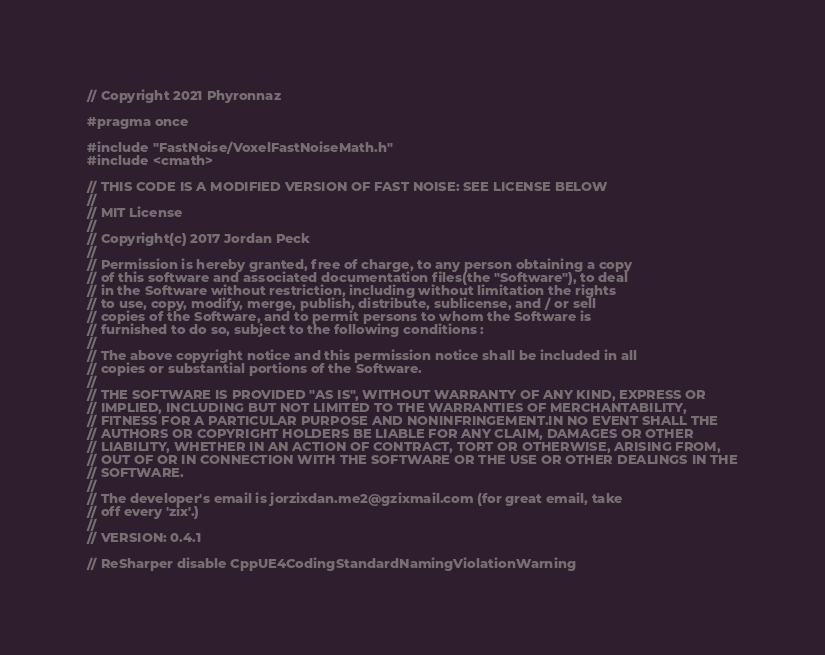Convert code to text. <code><loc_0><loc_0><loc_500><loc_500><_C++_>// Copyright 2021 Phyronnaz

#pragma once

#include "FastNoise/VoxelFastNoiseMath.h"
#include <cmath>

// THIS CODE IS A MODIFIED VERSION OF FAST NOISE: SEE LICENSE BELOW
//
// MIT License
//
// Copyright(c) 2017 Jordan Peck
//
// Permission is hereby granted, free of charge, to any person obtaining a copy
// of this software and associated documentation files(the "Software"), to deal
// in the Software without restriction, including without limitation the rights
// to use, copy, modify, merge, publish, distribute, sublicense, and / or sell
// copies of the Software, and to permit persons to whom the Software is
// furnished to do so, subject to the following conditions :
//
// The above copyright notice and this permission notice shall be included in all
// copies or substantial portions of the Software.
//
// THE SOFTWARE IS PROVIDED "AS IS", WITHOUT WARRANTY OF ANY KIND, EXPRESS OR
// IMPLIED, INCLUDING BUT NOT LIMITED TO THE WARRANTIES OF MERCHANTABILITY,
// FITNESS FOR A PARTICULAR PURPOSE AND NONINFRINGEMENT.IN NO EVENT SHALL THE
// AUTHORS OR COPYRIGHT HOLDERS BE LIABLE FOR ANY CLAIM, DAMAGES OR OTHER
// LIABILITY, WHETHER IN AN ACTION OF CONTRACT, TORT OR OTHERWISE, ARISING FROM,
// OUT OF OR IN CONNECTION WITH THE SOFTWARE OR THE USE OR OTHER DEALINGS IN THE
// SOFTWARE.
//
// The developer's email is jorzixdan.me2@gzixmail.com (for great email, take
// off every 'zix'.)
//
// VERSION: 0.4.1

// ReSharper disable CppUE4CodingStandardNamingViolationWarning
</code> 